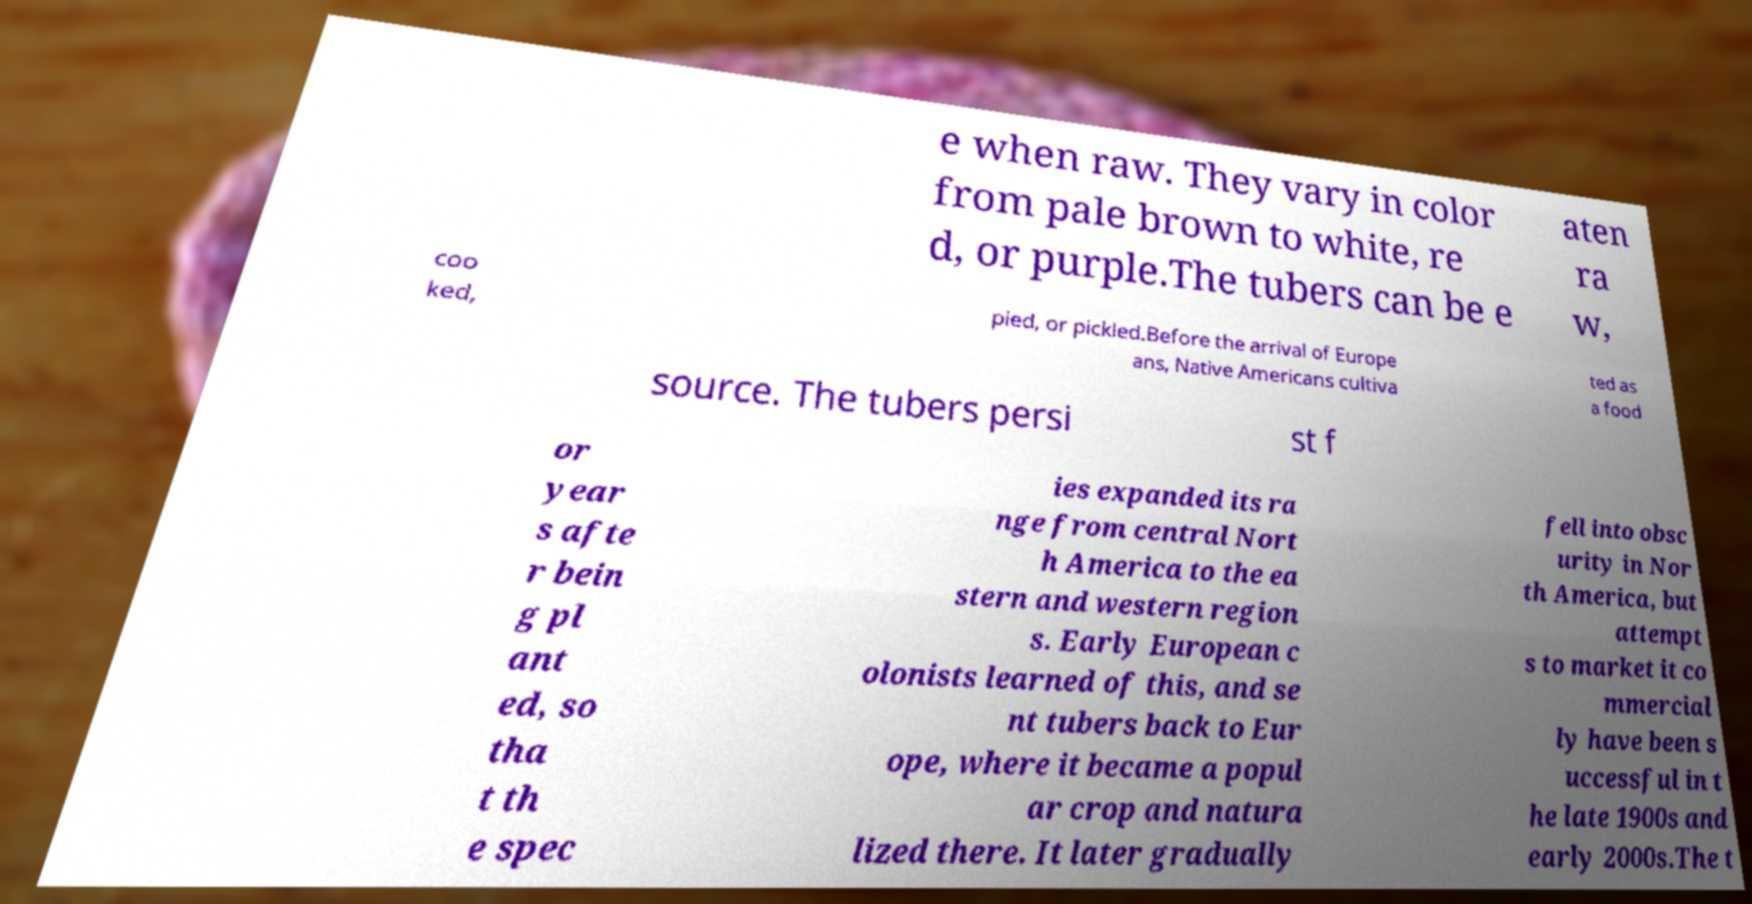For documentation purposes, I need the text within this image transcribed. Could you provide that? e when raw. They vary in color from pale brown to white, re d, or purple.The tubers can be e aten ra w, coo ked, pied, or pickled.Before the arrival of Europe ans, Native Americans cultiva ted as a food source. The tubers persi st f or year s afte r bein g pl ant ed, so tha t th e spec ies expanded its ra nge from central Nort h America to the ea stern and western region s. Early European c olonists learned of this, and se nt tubers back to Eur ope, where it became a popul ar crop and natura lized there. It later gradually fell into obsc urity in Nor th America, but attempt s to market it co mmercial ly have been s uccessful in t he late 1900s and early 2000s.The t 